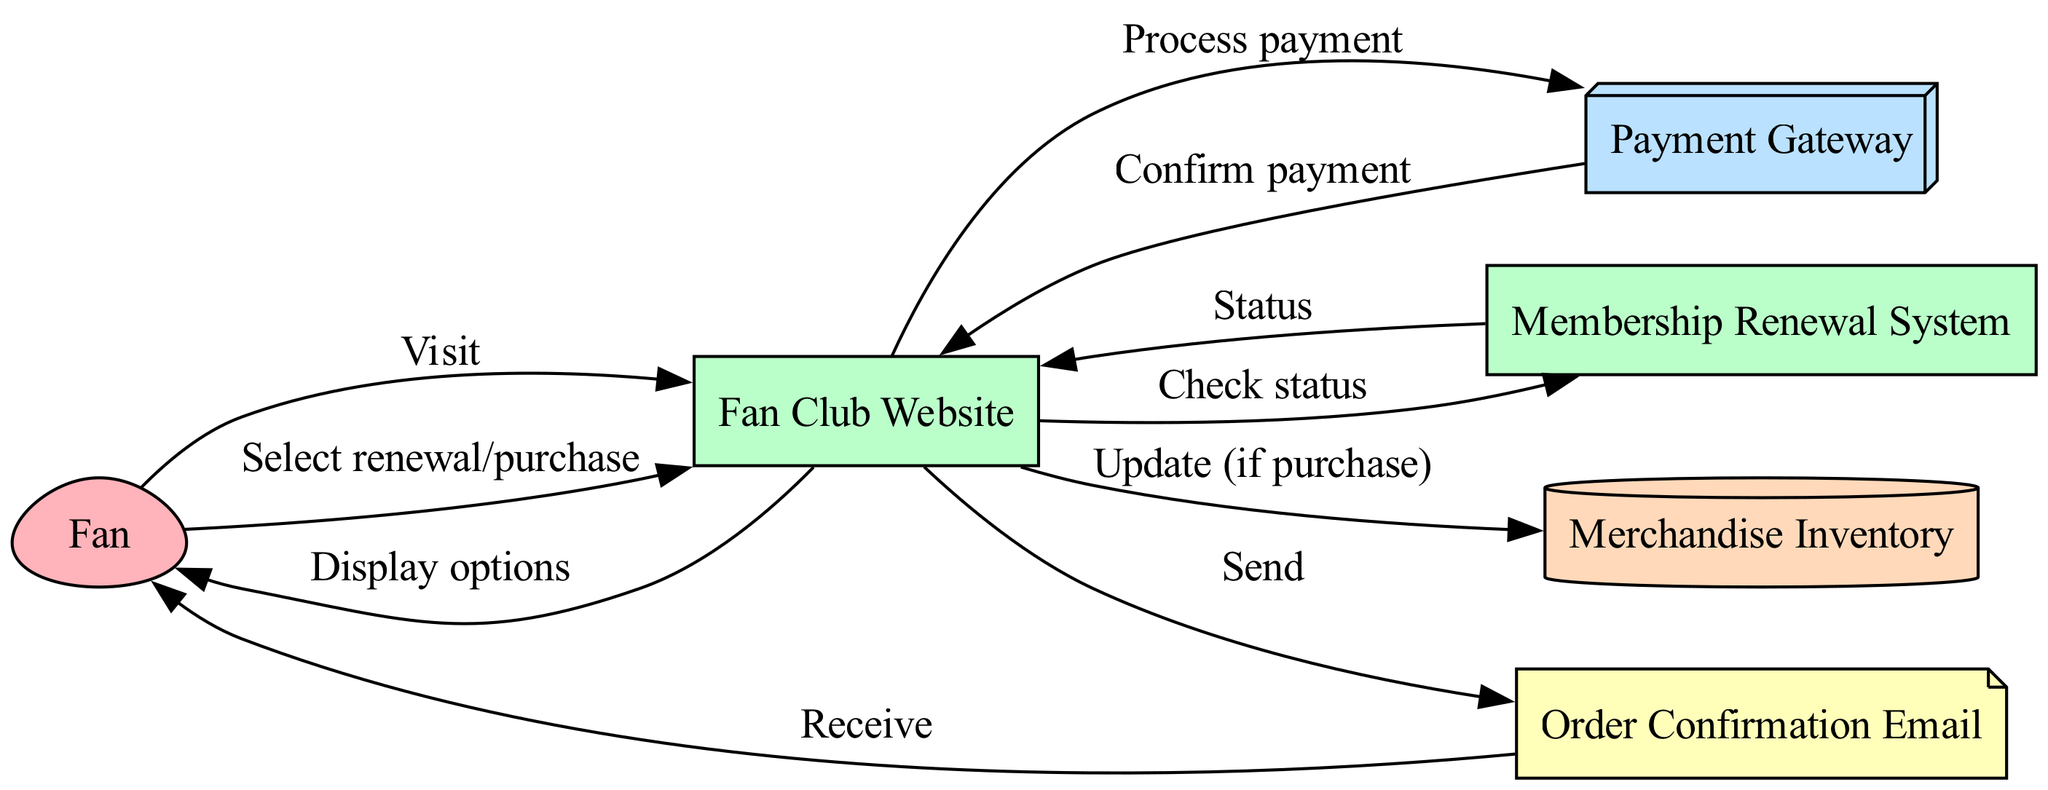What is the name of the first actor in the diagram? The first actor listed in the diagram is 'Fan'. This is determined by looking at the 'elements' section where 'Fan' is mentioned as an actor.
Answer: Fan How many systems are represented in the diagram? By examining the 'elements' section, there are three systems: 'Fan Club Website', 'Membership Renewal System', and 'Payment Gateway'. Thus, the count is three.
Answer: 3 What is the first action taken by the Fan? The first action initiated by the Fan is to 'Visit' the 'Fan Club Website'. This is indicated by the directed edge from 'Fan' to 'Fan Club Website'.
Answer: Visit What happens after the Fan Club Website checks the status? After the status is checked by the 'Membership Renewal System', it sends back a 'Status' to the 'Fan Club Website'. This flow is observed in the sequence between these two nodes.
Answer: Status Which node does the Order Confirmation Email send information to? The 'Order Confirmation Email' sends confirmation to the 'Fan', as shown by the directed edge leading from the email to the fan.
Answer: Fan How many edges are there in total in the diagram? Counting the edges, there are a total of eight edges representing interactions between the various components in the sequence diagram.
Answer: 8 What type of event does the Fan Club Website perform after a payment is confirmed? Following the confirmation of payment, the 'Fan Club Website' processes an 'Update' in the 'Merchandise Inventory'. This is depicted in the relationship stemming from the website to the inventory.
Answer: Update What type of element is 'Payment Gateway'? The 'Payment Gateway' is categorized as an 'external system', as identified in the type classification in the elements section of the diagram.
Answer: external system What notification is sent to the Fan after the order confirmation? The notification sent to the 'Fan' after the order confirmation is an 'Order Confirmation Email'. This relationship is illustrated with a directed edge from the email to the fan.
Answer: Order Confirmation Email 